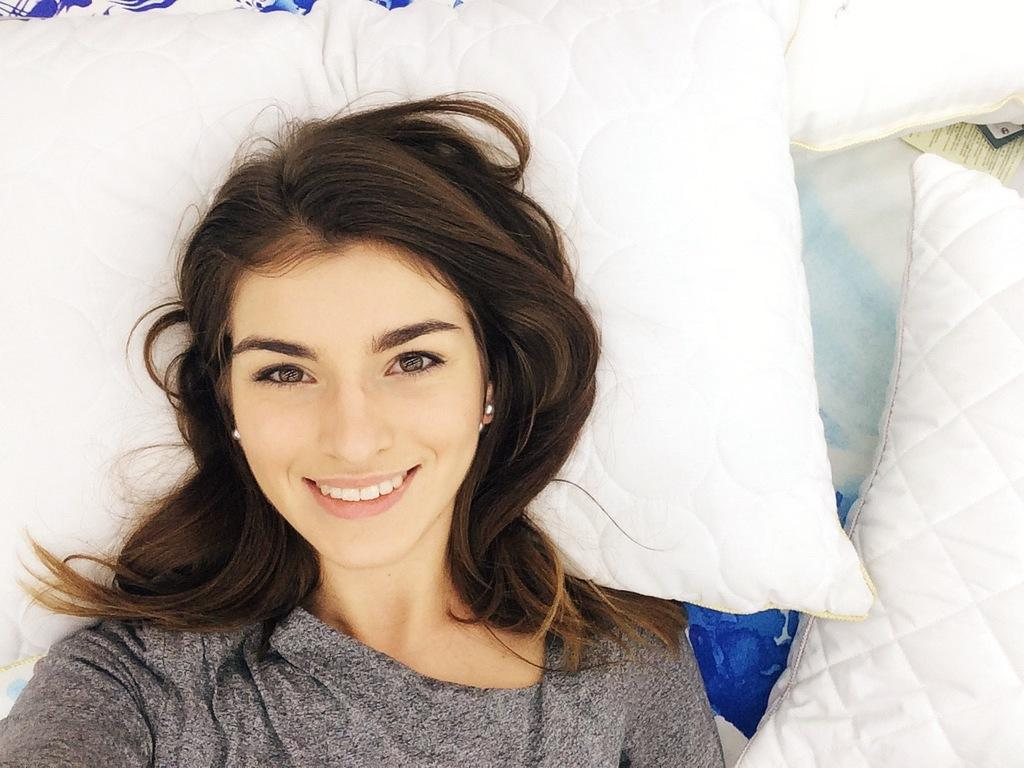Who is the main subject in the foreground of the image? There is a woman in the foreground of the image. What is the woman doing in the image? The woman is lying on a bed. Are there any additional objects or features in the image? Yes, cushions are present in the image. Can you describe the setting of the image? The image is likely taken in a room, as it features a bed and cushions. What type of milk is being poured onto the cushions in the image? There is no milk present in the image, and therefore no such action is taking place. 